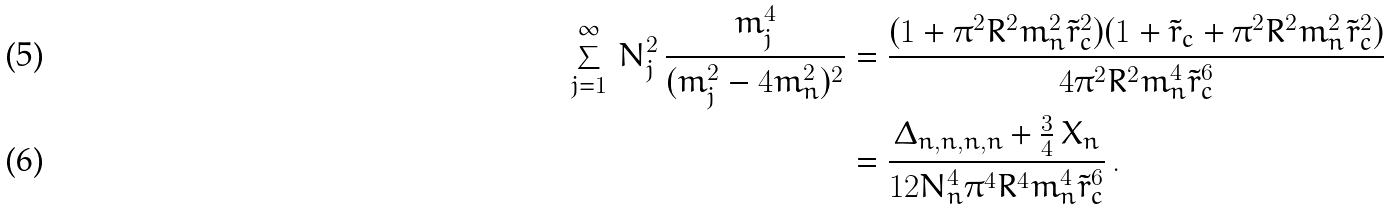<formula> <loc_0><loc_0><loc_500><loc_500>\sum _ { j = 1 } ^ { \infty } \, N _ { j } ^ { 2 } \, \frac { m _ { j } ^ { 4 } } { ( m _ { j } ^ { 2 } - 4 m _ { n } ^ { 2 } ) ^ { 2 } } & = \frac { ( 1 + \pi ^ { 2 } R ^ { 2 } m _ { n } ^ { 2 } \tilde { r } _ { c } ^ { 2 } ) ( 1 + \tilde { r } _ { c } + \pi ^ { 2 } R ^ { 2 } m _ { n } ^ { 2 } \tilde { r } _ { c } ^ { 2 } ) } { 4 \pi ^ { 2 } R ^ { 2 } m _ { n } ^ { 4 } \tilde { r } _ { c } ^ { 6 } } \\ & = \frac { \Delta _ { n , n , n , n } + \frac { 3 } { 4 } \, X _ { n } } { 1 2 N _ { n } ^ { 4 } \pi ^ { 4 } R ^ { 4 } m _ { n } ^ { 4 } \tilde { r } _ { c } ^ { 6 } } \, .</formula> 